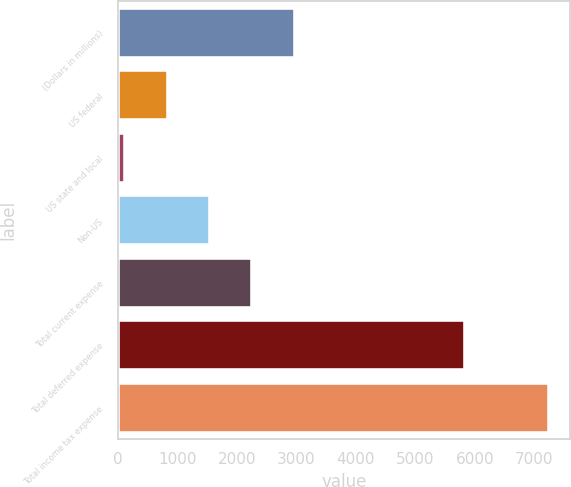Convert chart. <chart><loc_0><loc_0><loc_500><loc_500><bar_chart><fcel>(Dollars in millions)<fcel>US federal<fcel>US state and local<fcel>Non-US<fcel>Total current expense<fcel>Total deferred expense<fcel>Total income tax expense<nl><fcel>2970.8<fcel>832.7<fcel>120<fcel>1545.4<fcel>2258.1<fcel>5841<fcel>7247<nl></chart> 